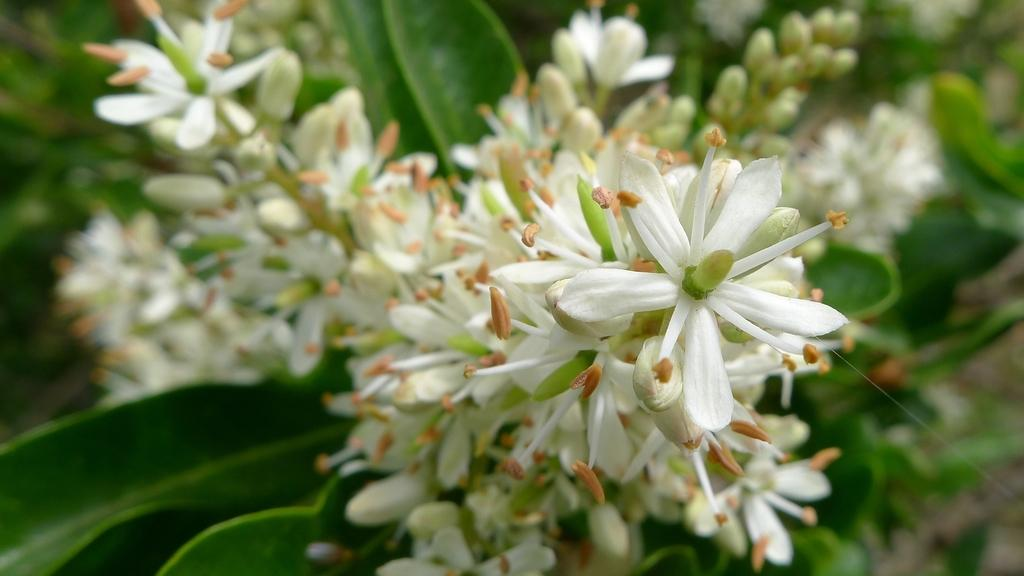What type of plants can be seen in the image? There are flowers, buds, and green leaves in the image. Can you describe the growth stage of the plants in the image? The image shows both flowers and buds, indicating that the plants are in different stages of growth. What color are the leaves in the image? The leaves in the image are green. What type of apparatus is used to cook the beef in the image? There is no beef or apparatus present in the image; it features flowers, buds, and green leaves. 